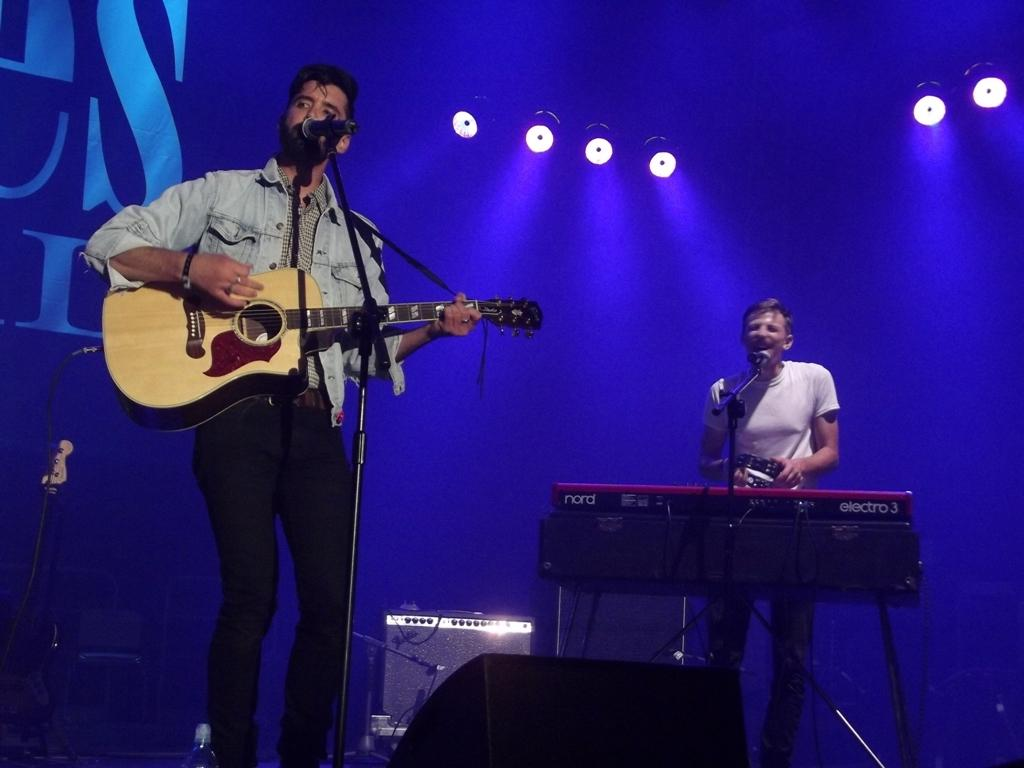What is the man in the image doing? The man in the image is singing. What is the man holding while singing? The man is holding a microphone. What other musical instrument is the man playing? The man is playing a guitar. Are there any other musicians in the image? Yes, there is another man playing a musical instrument. What can be seen in the image that provides light? There is a light visible in the image. How many eggs are on the table in the image? There are no eggs present in the image. What type of alarm is going off in the image? There is no alarm present in the image. 